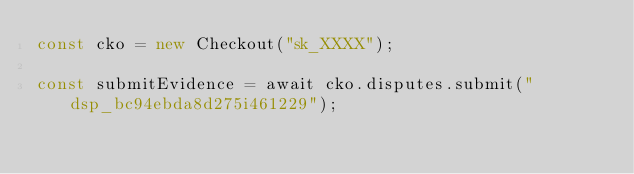<code> <loc_0><loc_0><loc_500><loc_500><_JavaScript_>const cko = new Checkout("sk_XXXX");

const submitEvidence = await cko.disputes.submit("dsp_bc94ebda8d275i461229");
</code> 